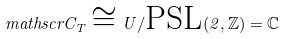<formula> <loc_0><loc_0><loc_500><loc_500>\ m a t h s c r { C } _ { T } \cong U / \text {PSL} ( 2 , \mathbb { Z } ) = \mathbb { C }</formula> 